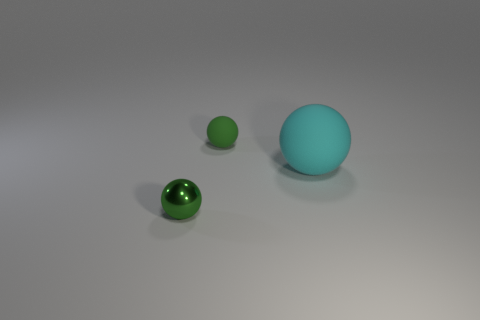Is there a yellow matte ball that has the same size as the green rubber ball?
Make the answer very short. No. Do the green object behind the cyan rubber thing and the small green metallic sphere have the same size?
Provide a short and direct response. Yes. What size is the metal object?
Offer a terse response. Small. What is the color of the small thing that is on the right side of the green object that is on the left side of the tiny green thing behind the big thing?
Your response must be concise. Green. Do the rubber thing that is to the right of the green rubber ball and the tiny shiny object have the same color?
Keep it short and to the point. No. How many objects are both right of the small matte ball and in front of the big cyan matte ball?
Your response must be concise. 0. The cyan rubber object that is the same shape as the metal object is what size?
Offer a terse response. Large. There is a small thing right of the green thing that is in front of the cyan rubber sphere; how many balls are in front of it?
Give a very brief answer. 2. The rubber ball that is in front of the thing behind the large object is what color?
Provide a short and direct response. Cyan. How many other objects are there of the same material as the big cyan ball?
Your response must be concise. 1. 